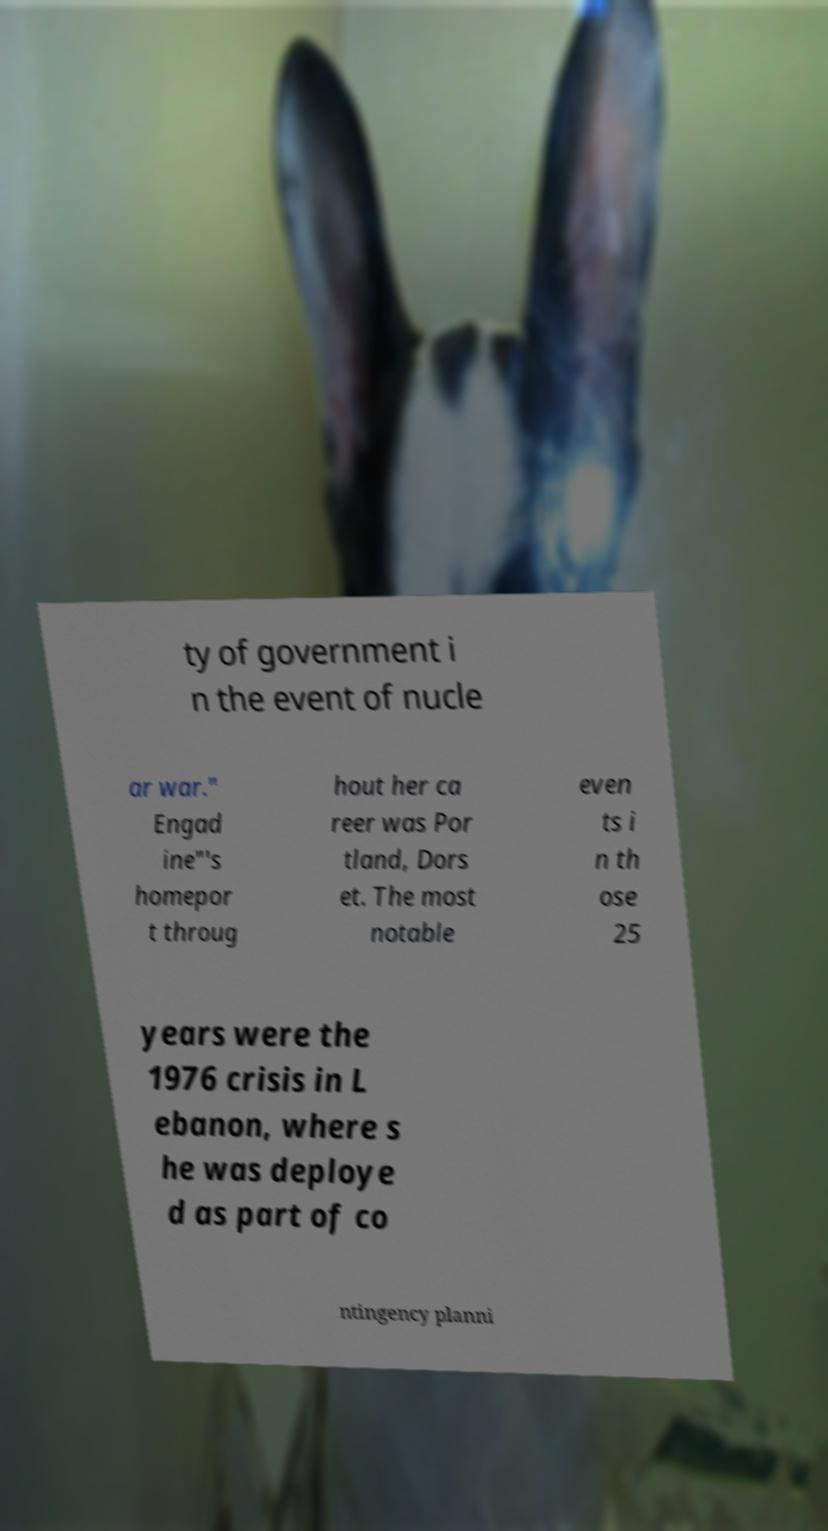Can you read and provide the text displayed in the image?This photo seems to have some interesting text. Can you extract and type it out for me? ty of government i n the event of nucle ar war." Engad ine"'s homepor t throug hout her ca reer was Por tland, Dors et. The most notable even ts i n th ose 25 years were the 1976 crisis in L ebanon, where s he was deploye d as part of co ntingency planni 